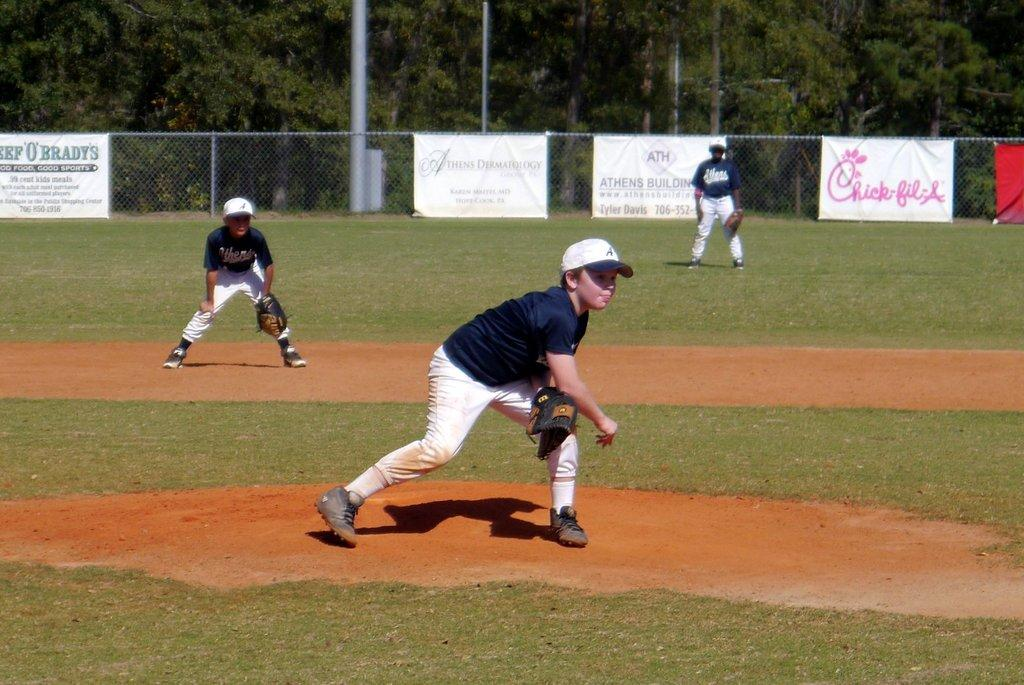<image>
Create a compact narrative representing the image presented. The little league baseball field is sponsored by Chick-fil-A. 